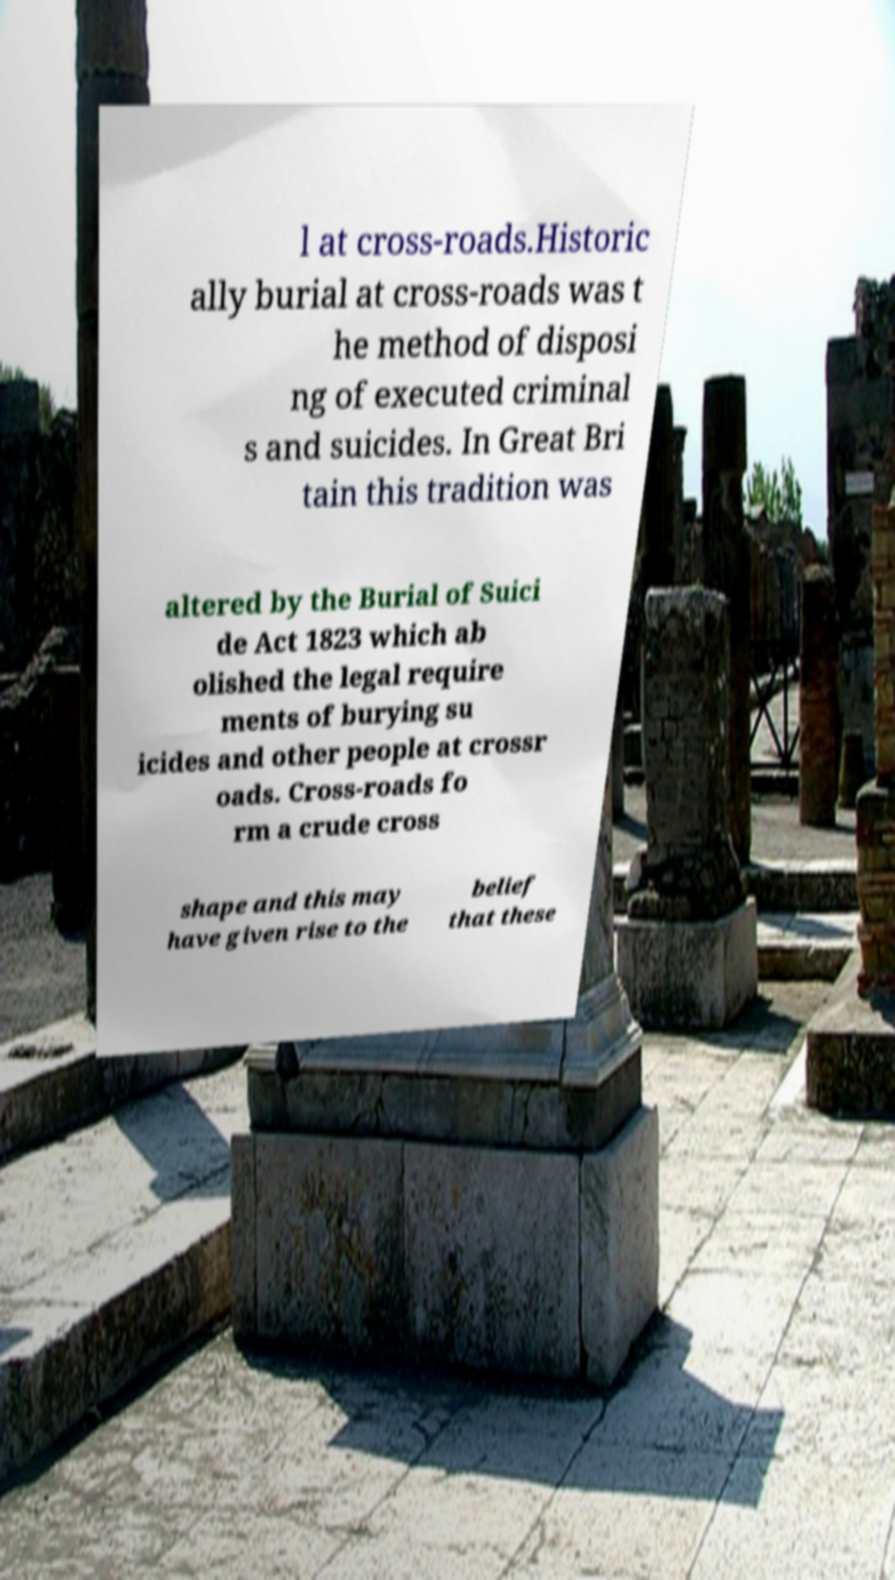Could you extract and type out the text from this image? l at cross-roads.Historic ally burial at cross-roads was t he method of disposi ng of executed criminal s and suicides. In Great Bri tain this tradition was altered by the Burial of Suici de Act 1823 which ab olished the legal require ments of burying su icides and other people at crossr oads. Cross-roads fo rm a crude cross shape and this may have given rise to the belief that these 